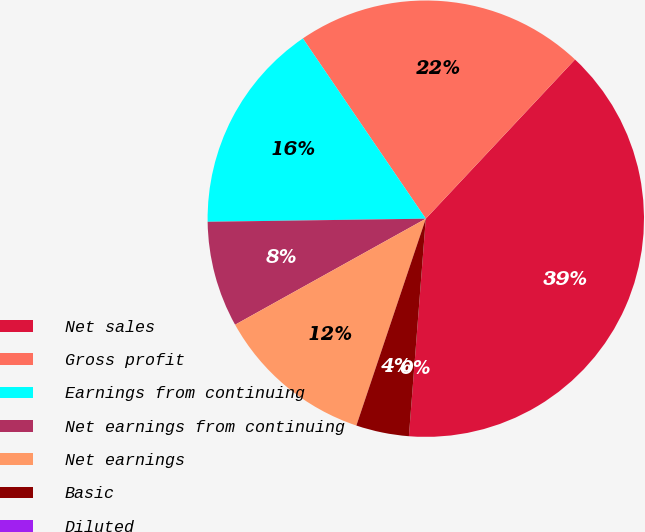Convert chart. <chart><loc_0><loc_0><loc_500><loc_500><pie_chart><fcel>Net sales<fcel>Gross profit<fcel>Earnings from continuing<fcel>Net earnings from continuing<fcel>Net earnings<fcel>Basic<fcel>Diluted<nl><fcel>39.25%<fcel>21.51%<fcel>15.7%<fcel>7.85%<fcel>11.77%<fcel>3.92%<fcel>0.0%<nl></chart> 